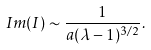Convert formula to latex. <formula><loc_0><loc_0><loc_500><loc_500>I m ( I ) \sim \frac { 1 } { a ( \lambda - 1 ) ^ { 3 / 2 } } .</formula> 